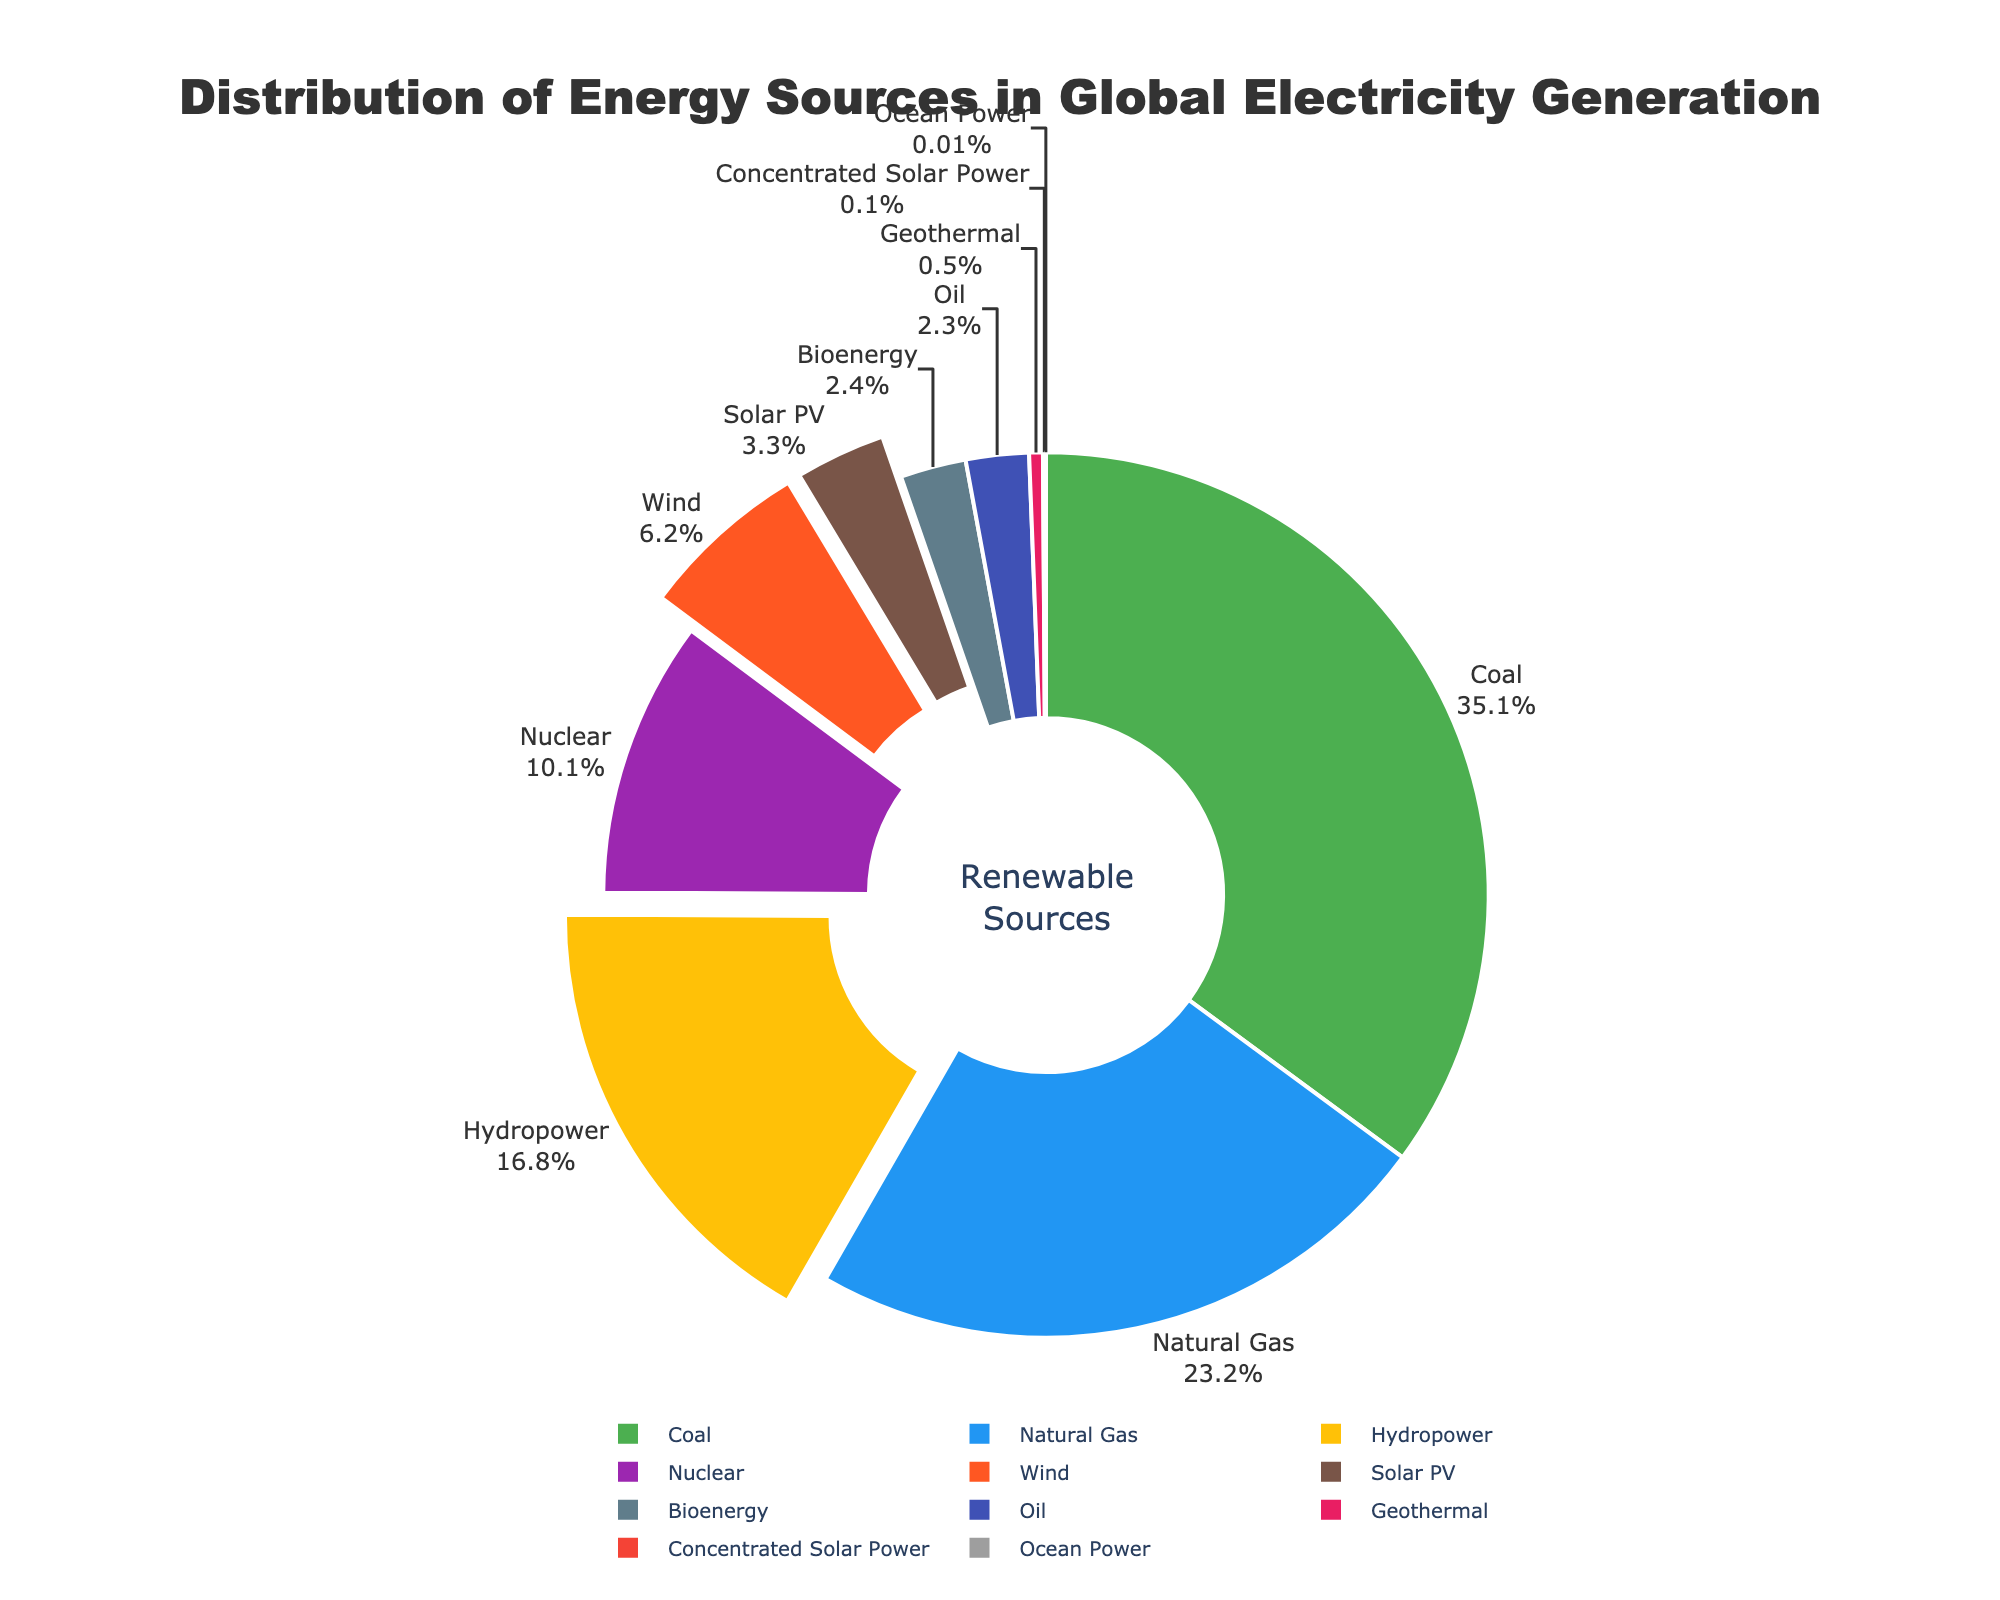Which energy source contributes the highest percentage to global electricity generation? The segment sizes in the pie chart indicate the percentage contribution of each source. The largest segment represents coal at 35.1%.
Answer: Coal What is the combined percentage of all renewable energy sources (Hydropower, Wind, Solar PV, Bioenergy, Geothermal, Concentrated Solar Power, Ocean Power)? Summing the percentages of Hydropower (16.8%), Wind (6.2%), Solar PV (3.3%), Bioenergy (2.4%), Geothermal (0.5%), Concentrated Solar Power (0.1%), and Ocean Power (0.01%) gives 29.31%.
Answer: 29.31% Which renewable energy source has the smallest contribution, and what is its percentage? The smallest segment among renewable sources is Ocean Power, contributing 0.01%.
Answer: Ocean Power, 0.01% How do the contributions of Wind and Solar PV compare to each other? Wind contributes 6.2%, while Solar PV contributes 3.3%. Wind's contribution is greater.
Answer: Wind is greater than Solar PV What is the difference in percentage contribution between Hydropower and Nuclear energy? Hydropower contributes 16.8% and Nuclear energy contributes 10.1%. The difference is 16.8% - 10.1% = 6.7%.
Answer: 6.7% Which non-renewable energy source has the higher contribution to global electricity generation, Natural Gas or Oil? The segment sizes show Natural Gas at 23.2% and Oil at 2.3%. Natural Gas has a higher contribution.
Answer: Natural Gas What percentage of global electricity generation comes from fossil fuels (Natural Gas, Coal, Oil)? Adding the percentages of Natural Gas (23.2%), Coal (35.1%), and Oil (2.3%) gives 60.6%.
Answer: 60.6% Which two energy sources are closest in their percentages, and what are those percentages? Bioenergy at 2.4% and Oil at 2.3% are the closest in their segment sizes.
Answer: Bioenergy (2.4%) and Oil (2.3%) What is the total percentage for non-renewable sources listed (Nuclear, Natural Gas, Coal, Oil)? Summing the percentages of Nuclear (10.1%), Natural Gas (23.2%), Coal (35.1%), and Oil (2.3%) gives 70.7%.
Answer: 70.7% Which energy sources are highlighted by being pulled out from the pie chart? The segments pulled out are Hydropower, Wind, and Solar PV.
Answer: Hydropower, Wind, Solar PV 